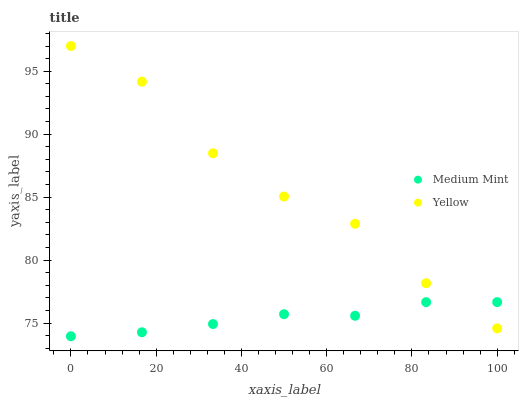Does Medium Mint have the minimum area under the curve?
Answer yes or no. Yes. Does Yellow have the maximum area under the curve?
Answer yes or no. Yes. Does Yellow have the minimum area under the curve?
Answer yes or no. No. Is Medium Mint the smoothest?
Answer yes or no. Yes. Is Yellow the roughest?
Answer yes or no. Yes. Is Yellow the smoothest?
Answer yes or no. No. Does Medium Mint have the lowest value?
Answer yes or no. Yes. Does Yellow have the lowest value?
Answer yes or no. No. Does Yellow have the highest value?
Answer yes or no. Yes. Does Medium Mint intersect Yellow?
Answer yes or no. Yes. Is Medium Mint less than Yellow?
Answer yes or no. No. Is Medium Mint greater than Yellow?
Answer yes or no. No. 